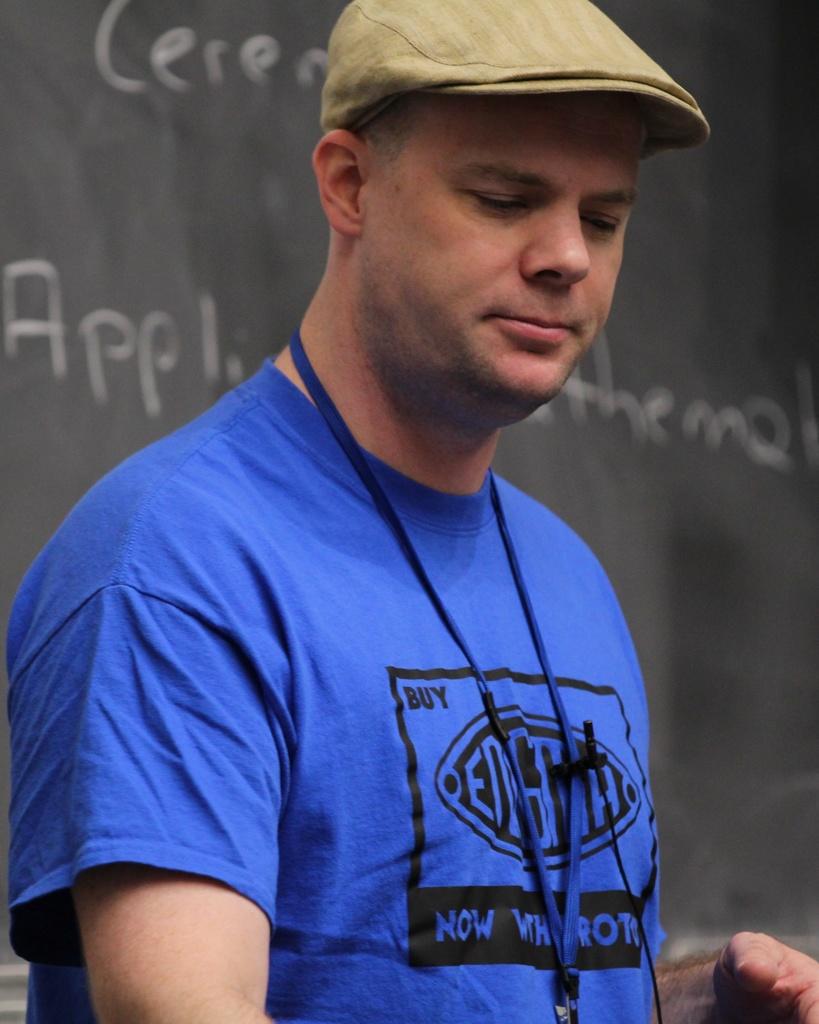Does his shirt have the word "buy" on it?
Give a very brief answer. Yes. What does his shirt say?
Provide a succinct answer. Unanswerable. 